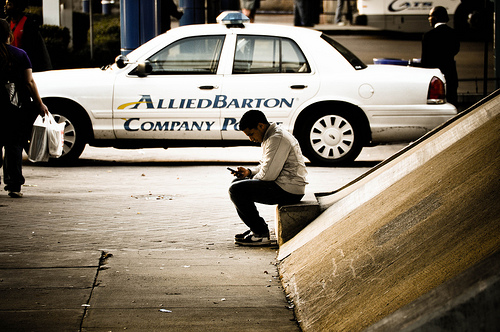Where could this place be located? This place could likely be situated in an urban setting, possibly downtown or near a commercial center given the presence of the company police car and pedestrian activity. What is the significance of the police car in this context? The presence of the police car, marked with 'ALLIEDBARTON Company Police', could suggest that this area is under surveillance or protection, possibly due to it being a company premises or a location needing additional security. Create a hypothetical scenario explaining why the company police car is there. In this scenario, the company police car is parked near the entrance of a large corporate building. Inside, a security conference is taking place, gathering the top professionals from different industries. The man sitting outside is a conference attendee, taking a moment to catch up on emails. The increased security is due to the high-profile nature of the event and the presence of dignitaries from various sectors. The car's presence secures the perimeter, ensuring attendees feel safe and any potential threats are deterred. As the man sits, engrossed in his phone, inside the building, discussions on the future of corporate security policies are in full swing, shaping the safeguards of tomorrow. 